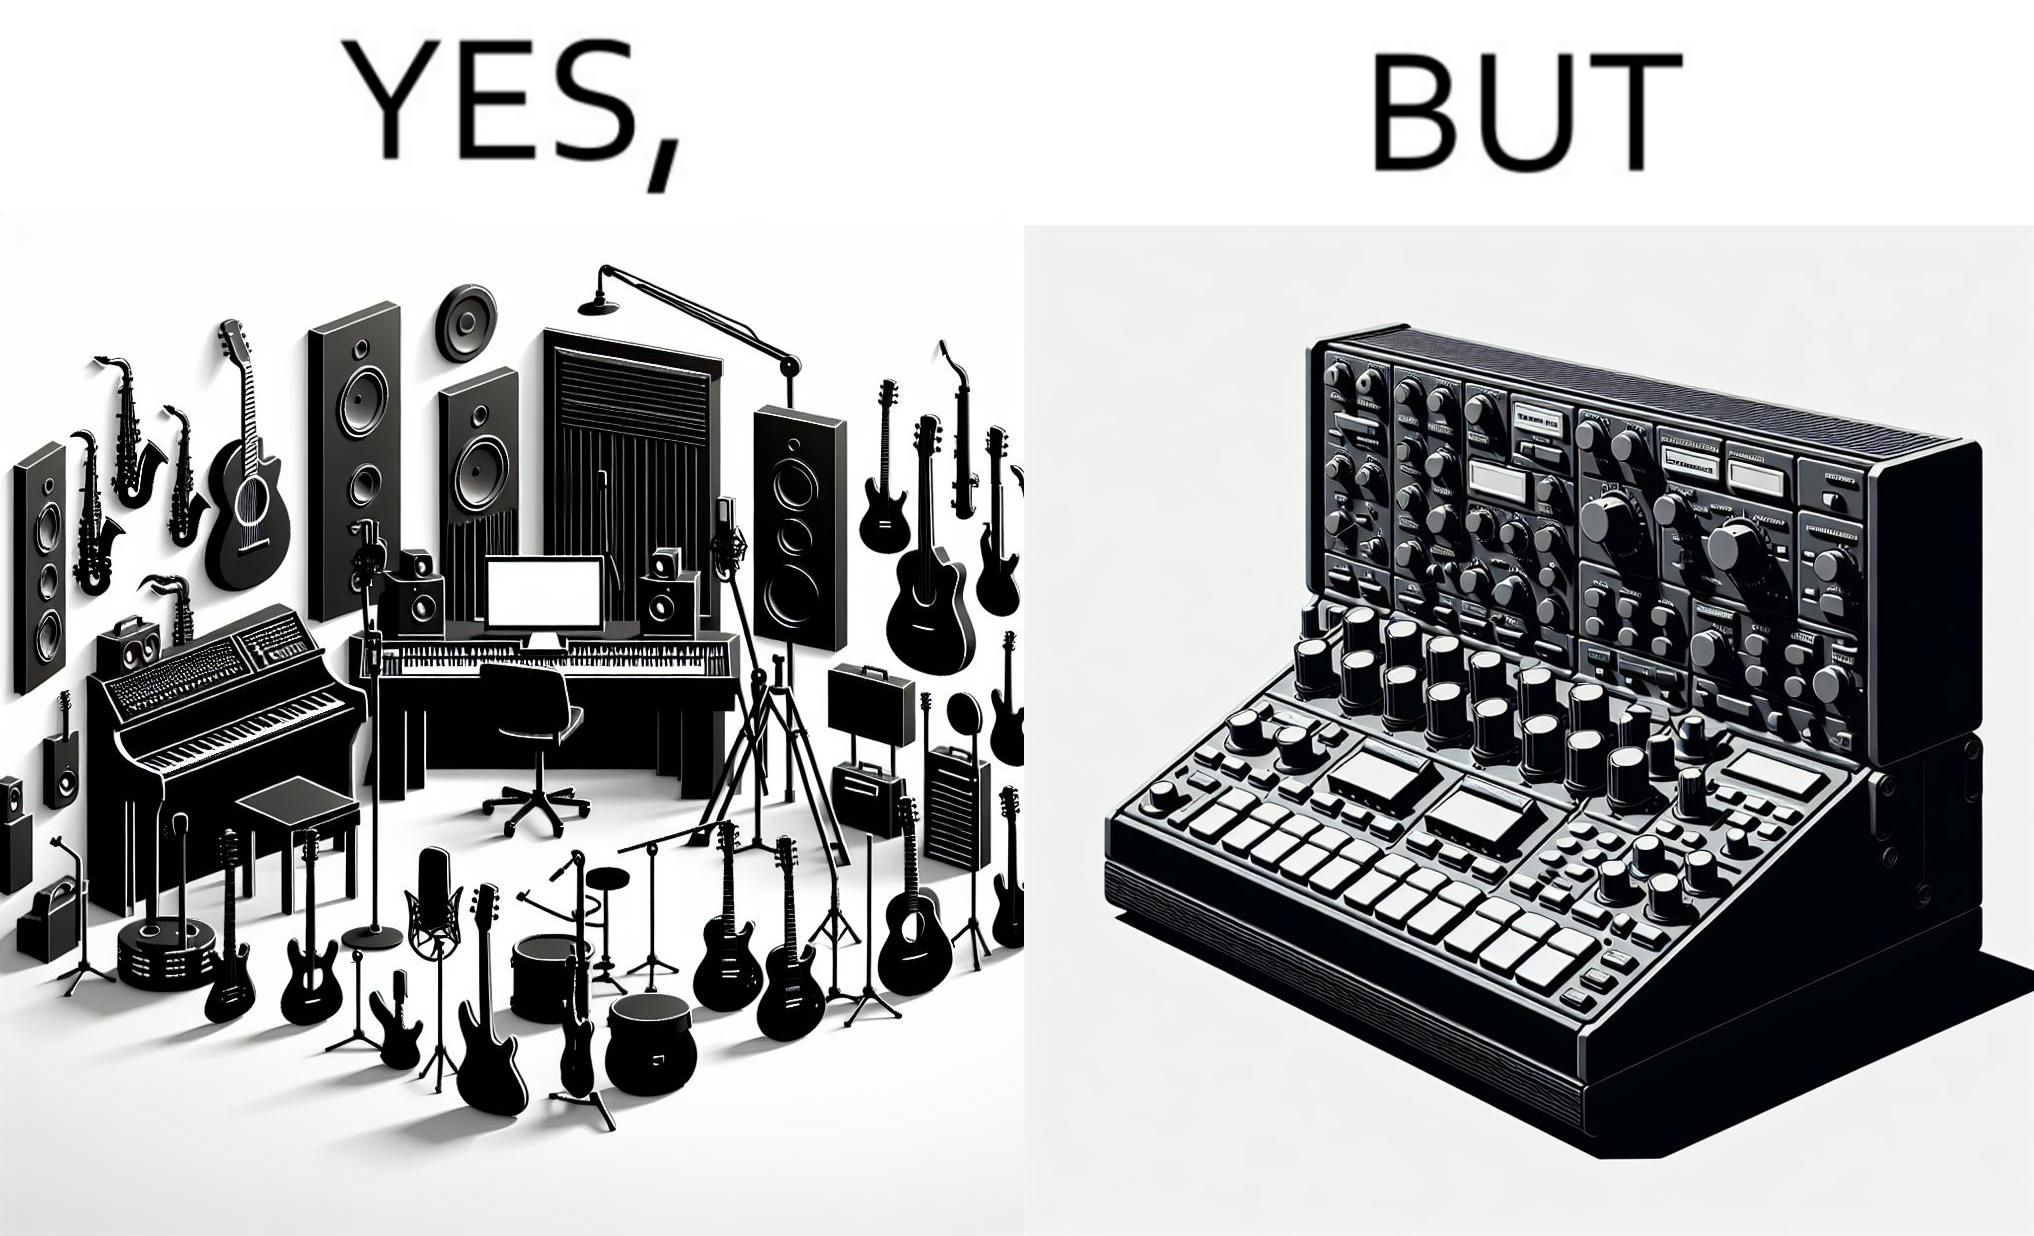Provide a description of this image. The image overall is funny because even though people have great music studios and instruments to create and record music, they use electronic replacements of the musical instruments to achieve the task. 